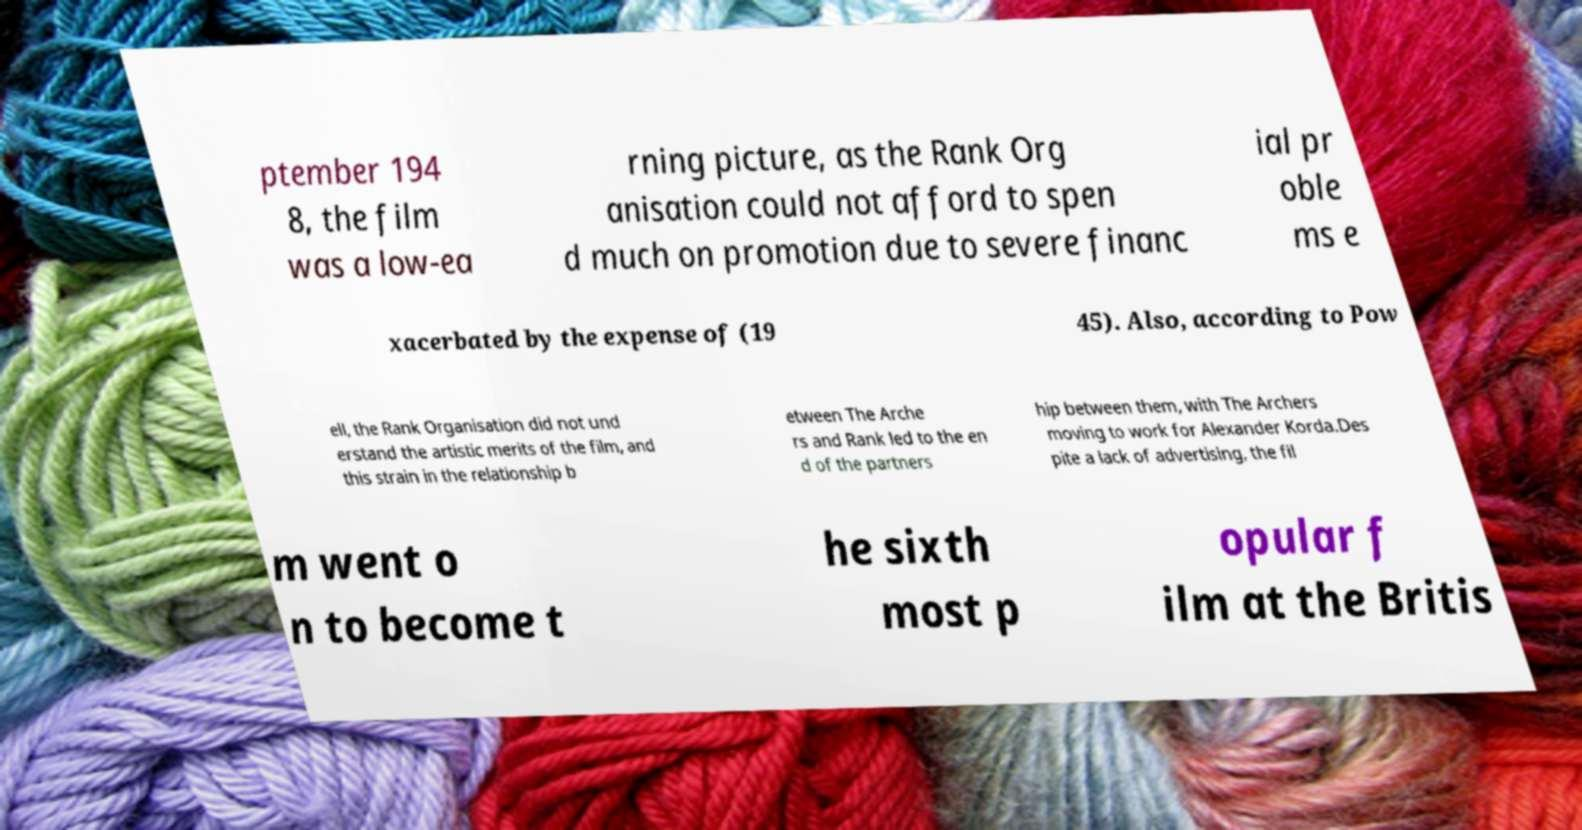I need the written content from this picture converted into text. Can you do that? ptember 194 8, the film was a low-ea rning picture, as the Rank Org anisation could not afford to spen d much on promotion due to severe financ ial pr oble ms e xacerbated by the expense of (19 45). Also, according to Pow ell, the Rank Organisation did not und erstand the artistic merits of the film, and this strain in the relationship b etween The Arche rs and Rank led to the en d of the partners hip between them, with The Archers moving to work for Alexander Korda.Des pite a lack of advertising, the fil m went o n to become t he sixth most p opular f ilm at the Britis 